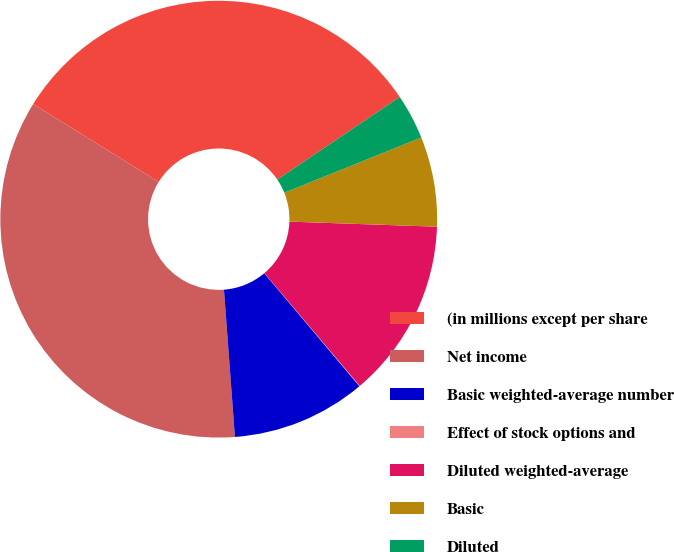<chart> <loc_0><loc_0><loc_500><loc_500><pie_chart><fcel>(in millions except per share<fcel>Net income<fcel>Basic weighted-average number<fcel>Effect of stock options and<fcel>Diluted weighted-average<fcel>Basic<fcel>Diluted<nl><fcel>31.71%<fcel>35.02%<fcel>9.96%<fcel>0.04%<fcel>13.27%<fcel>6.65%<fcel>3.35%<nl></chart> 